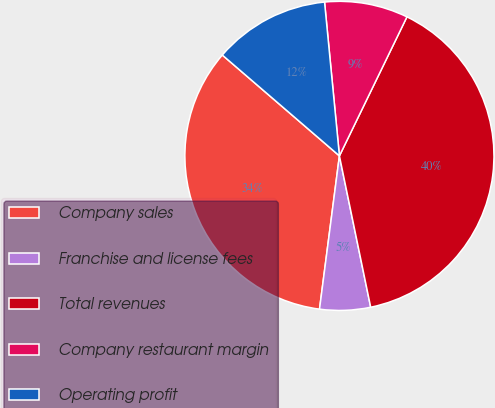<chart> <loc_0><loc_0><loc_500><loc_500><pie_chart><fcel>Company sales<fcel>Franchise and license fees<fcel>Total revenues<fcel>Company restaurant margin<fcel>Operating profit<nl><fcel>34.26%<fcel>5.3%<fcel>39.56%<fcel>8.73%<fcel>12.15%<nl></chart> 